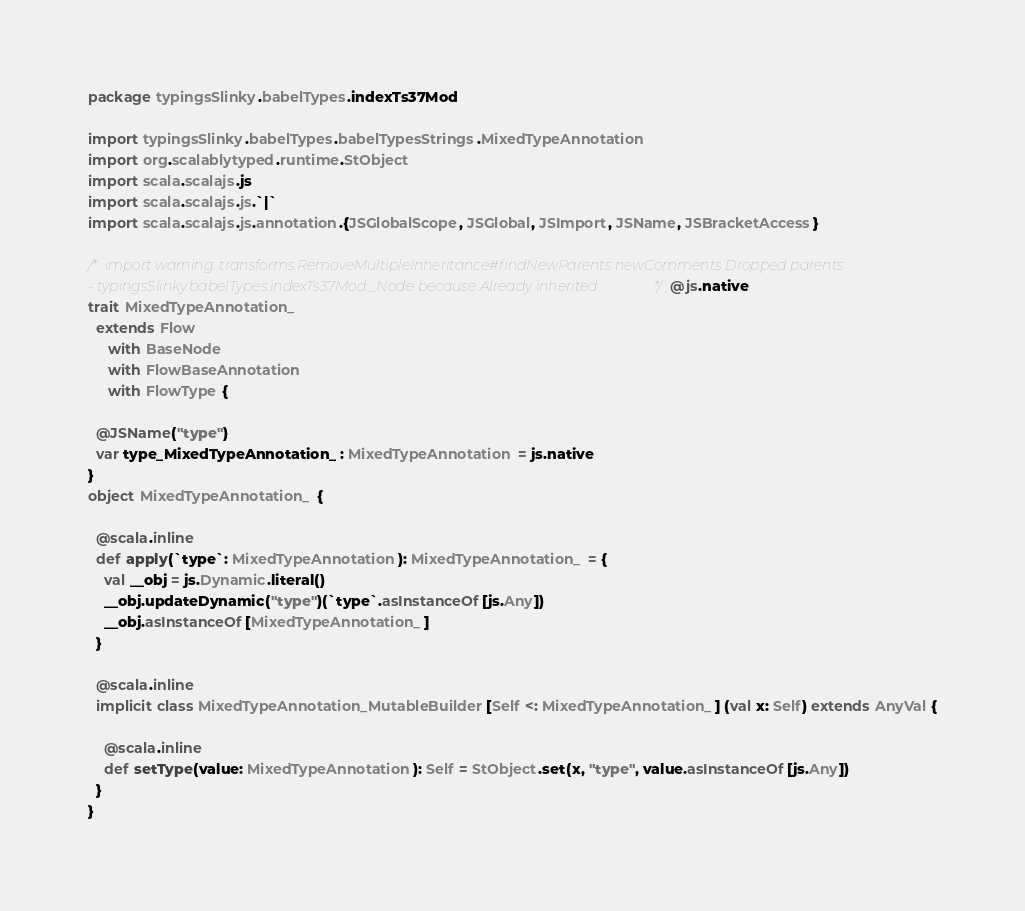Convert code to text. <code><loc_0><loc_0><loc_500><loc_500><_Scala_>package typingsSlinky.babelTypes.indexTs37Mod

import typingsSlinky.babelTypes.babelTypesStrings.MixedTypeAnnotation
import org.scalablytyped.runtime.StObject
import scala.scalajs.js
import scala.scalajs.js.`|`
import scala.scalajs.js.annotation.{JSGlobalScope, JSGlobal, JSImport, JSName, JSBracketAccess}

/* import warning: transforms.RemoveMultipleInheritance#findNewParents newComments Dropped parents 
- typingsSlinky.babelTypes.indexTs37Mod._Node because Already inherited */ @js.native
trait MixedTypeAnnotation_
  extends Flow
     with BaseNode
     with FlowBaseAnnotation
     with FlowType {
  
  @JSName("type")
  var type_MixedTypeAnnotation_ : MixedTypeAnnotation = js.native
}
object MixedTypeAnnotation_ {
  
  @scala.inline
  def apply(`type`: MixedTypeAnnotation): MixedTypeAnnotation_ = {
    val __obj = js.Dynamic.literal()
    __obj.updateDynamic("type")(`type`.asInstanceOf[js.Any])
    __obj.asInstanceOf[MixedTypeAnnotation_]
  }
  
  @scala.inline
  implicit class MixedTypeAnnotation_MutableBuilder[Self <: MixedTypeAnnotation_] (val x: Self) extends AnyVal {
    
    @scala.inline
    def setType(value: MixedTypeAnnotation): Self = StObject.set(x, "type", value.asInstanceOf[js.Any])
  }
}
</code> 